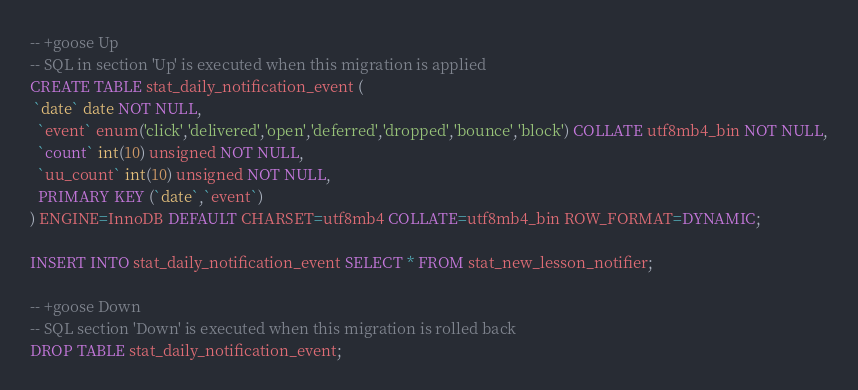Convert code to text. <code><loc_0><loc_0><loc_500><loc_500><_SQL_>-- +goose Up
-- SQL in section 'Up' is executed when this migration is applied
CREATE TABLE stat_daily_notification_event (
 `date` date NOT NULL,
  `event` enum('click','delivered','open','deferred','dropped','bounce','block') COLLATE utf8mb4_bin NOT NULL,
  `count` int(10) unsigned NOT NULL,
  `uu_count` int(10) unsigned NOT NULL,
  PRIMARY KEY (`date`,`event`)
) ENGINE=InnoDB DEFAULT CHARSET=utf8mb4 COLLATE=utf8mb4_bin ROW_FORMAT=DYNAMIC;

INSERT INTO stat_daily_notification_event SELECT * FROM stat_new_lesson_notifier;

-- +goose Down
-- SQL section 'Down' is executed when this migration is rolled back
DROP TABLE stat_daily_notification_event;
</code> 